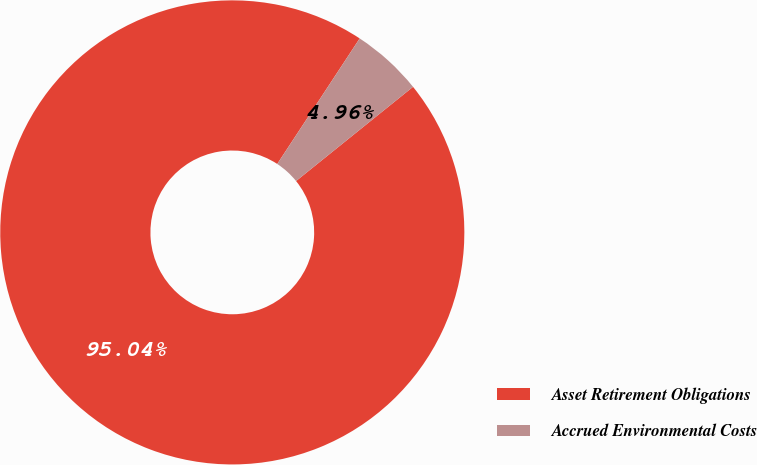Convert chart to OTSL. <chart><loc_0><loc_0><loc_500><loc_500><pie_chart><fcel>Asset Retirement Obligations<fcel>Accrued Environmental Costs<nl><fcel>95.04%<fcel>4.96%<nl></chart> 